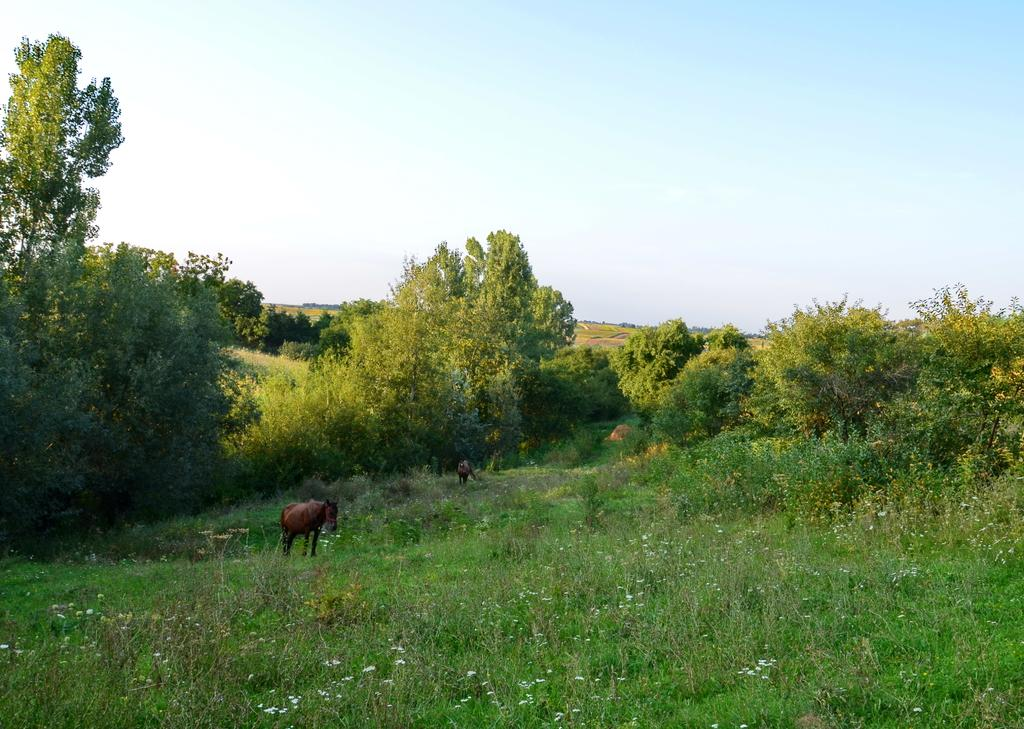What type of vegetation can be seen in the image? There are trees, grass, and bushes in the image. What else is present on the ground in the image? There are animals on the ground in the image. What is visible in the background of the image? The sky is visible in the image. What type of print can be seen on the office ball in the image? There is no office or ball present in the image; it features trees, animals, grass, bushes, and the sky. 